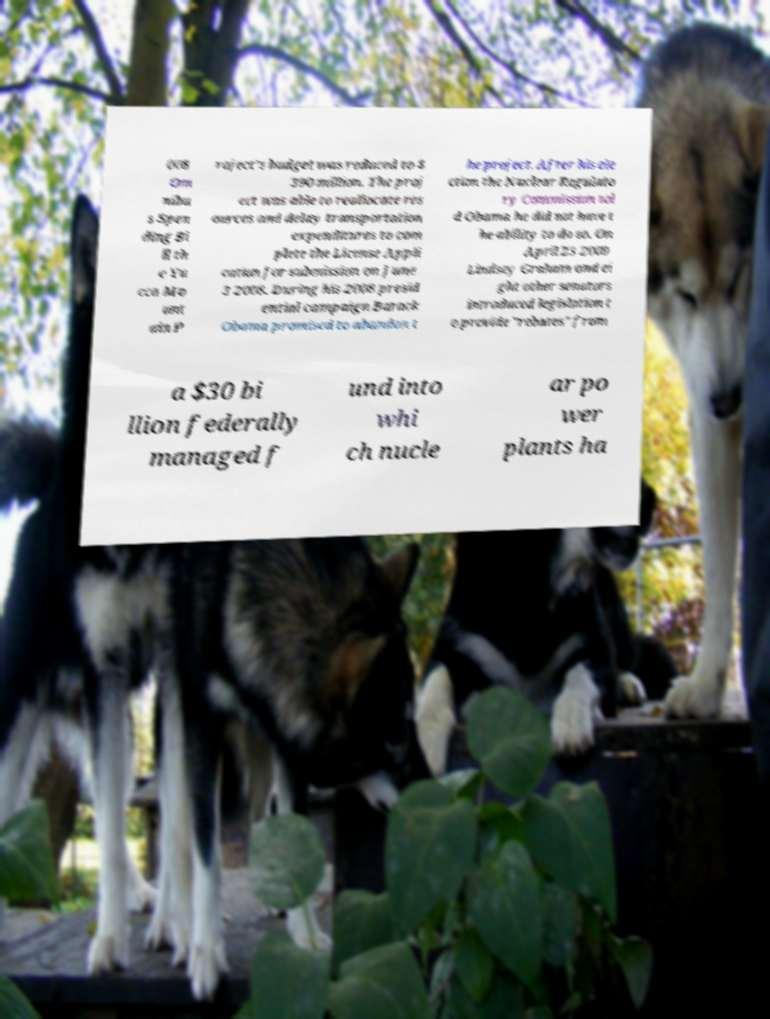Please read and relay the text visible in this image. What does it say? 008 Om nibu s Spen ding Bi ll th e Yu cca Mo unt ain P roject's budget was reduced to $ 390 million. The proj ect was able to reallocate res ources and delay transportation expenditures to com plete the License Appli cation for submission on June 3 2008. During his 2008 presid ential campaign Barack Obama promised to abandon t he project. After his ele ction the Nuclear Regulato ry Commission tol d Obama he did not have t he ability to do so. On April 23 2009 Lindsey Graham and ei ght other senators introduced legislation t o provide "rebates" from a $30 bi llion federally managed f und into whi ch nucle ar po wer plants ha 